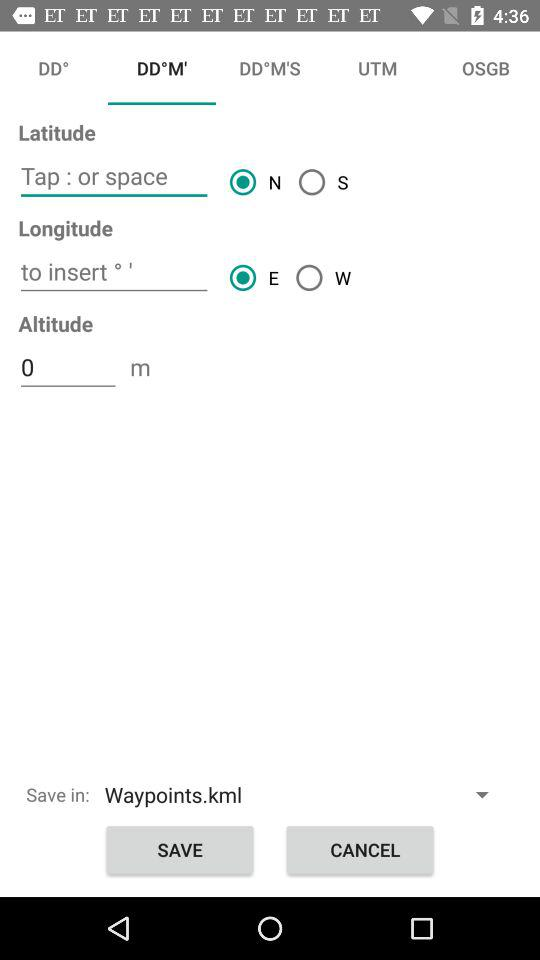What is the altitude? The altitude is 0 meters. 